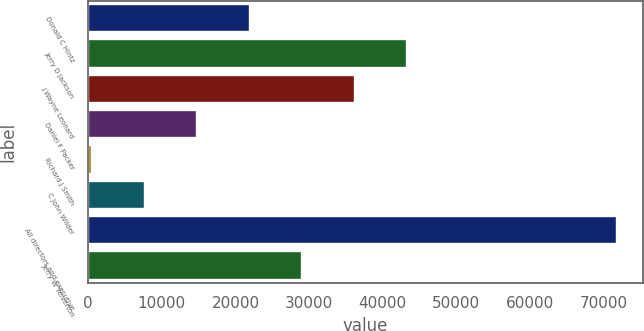Convert chart. <chart><loc_0><loc_0><loc_500><loc_500><bar_chart><fcel>Donald C Hintz<fcel>Jerry D Jackson<fcel>J Wayne Leonard<fcel>Daniel F Packer<fcel>Richard J Smith<fcel>C John Wilder<fcel>All directors and executive<fcel>Jerry W Yelverton<nl><fcel>21934<fcel>43294<fcel>36174<fcel>14814<fcel>574<fcel>7694<fcel>71774<fcel>29054<nl></chart> 